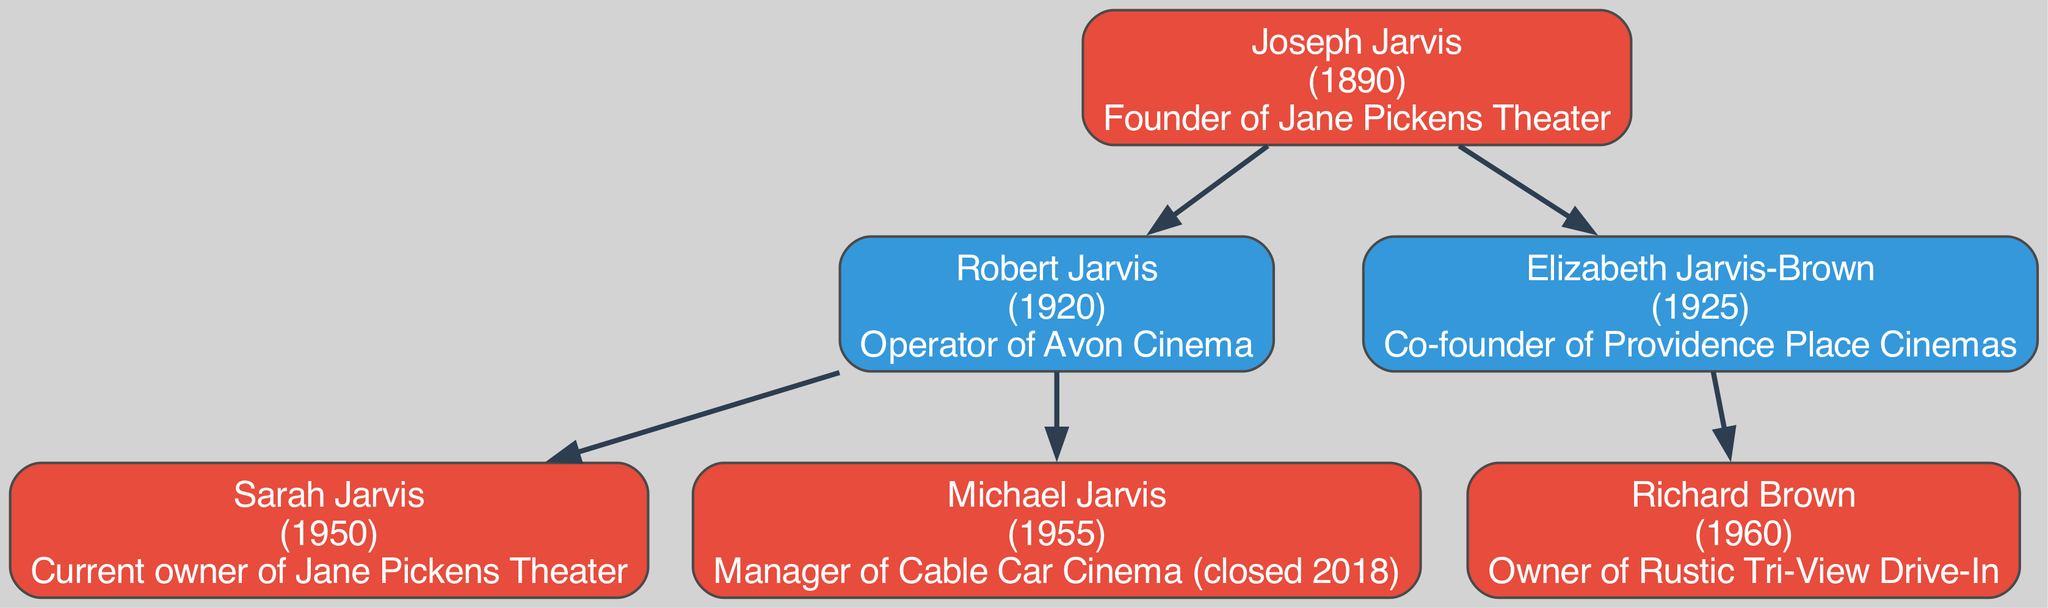What is the birth year of Joseph Jarvis? Joseph Jarvis is the root of the family tree, and his birth year is directly indicated in the diagram. The birth year stated next to his name is 1890.
Answer: 1890 Who operates the Avon Cinema? According to the family tree, the operator of Avon Cinema is mentioned under Robert Jarvis, who is a direct child of Joseph Jarvis. The role is clearly stated in Robert Jarvis's description.
Answer: Robert Jarvis How many children did Joseph Jarvis have? The diagram shows that Joseph Jarvis has two direct children listed, Robert Jarvis and Elizabeth Jarvis-Brown. This can be counted directly from the branches stemming from Joseph Jarvis.
Answer: 2 What is Sarah Jarvis's relationship to Joseph Jarvis? Sarah Jarvis is shown as a child of Robert Jarvis, who is the son of Joseph Jarvis, making Sarah Jarvis the granddaughter of Joseph Jarvis. This relationship can be traced through the family tree structure.
Answer: Granddaughter Which theater is currently owned by Sarah Jarvis? The diagram states that Sarah Jarvis is the current owner of Jane Pickens Theater. This information is directly provided in her role description within the tree.
Answer: Jane Pickens Theater Who is the owner of Rustic Tri-View Drive-In? Looking at Elizabeth Jarvis-Brown's children, we see Richard Brown is named as the owner of Rustic Tri-View Drive-In. This can be pinpointed directly through the lines connecting the nodes.
Answer: Richard Brown In what year was Robert Jarvis born? Directly linked to his node in the diagram, Robert Jarvis's birth year is mentioned as 1920. This is easily identifiable in the family tree layout.
Answer: 1920 How many generations are represented in this family tree? The diagram illustrates three generations: Joseph Jarvis (the founder), his children (Robert and Elizabeth), and their children (Sarah, Michael, and Richard). This can be counted by reviewing all the layers of the tree.
Answer: 3 What role did Elizabeth Jarvis-Brown hold? The family tree indicates that Elizabeth Jarvis-Brown is a co-founder of Providence Place Cinemas. This role is explicitly stated next to her name.
Answer: Co-founder of Providence Place Cinemas 